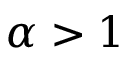<formula> <loc_0><loc_0><loc_500><loc_500>\alpha > 1</formula> 